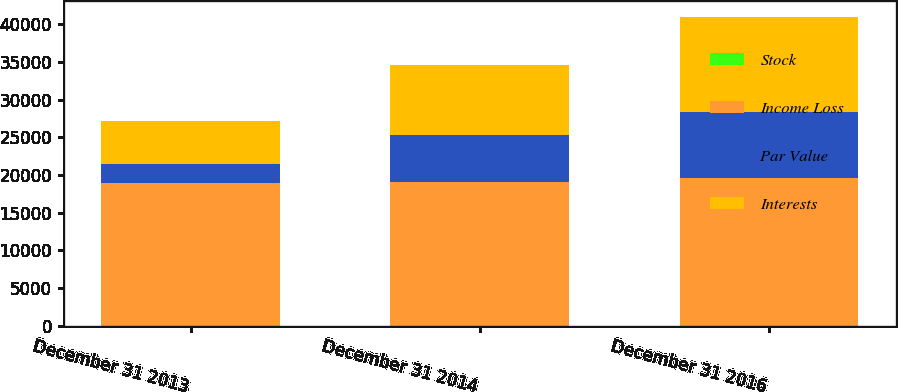Convert chart. <chart><loc_0><loc_0><loc_500><loc_500><stacked_bar_chart><ecel><fcel>December 31 2013<fcel>December 31 2014<fcel>December 31 2016<nl><fcel>Stock<fcel>6<fcel>6<fcel>6<nl><fcel>Income Loss<fcel>18887<fcel>19040<fcel>19559<nl><fcel>Par Value<fcel>2602<fcel>6234<fcel>8788<nl><fcel>Interests<fcel>5622<fcel>9309<fcel>12608<nl></chart> 